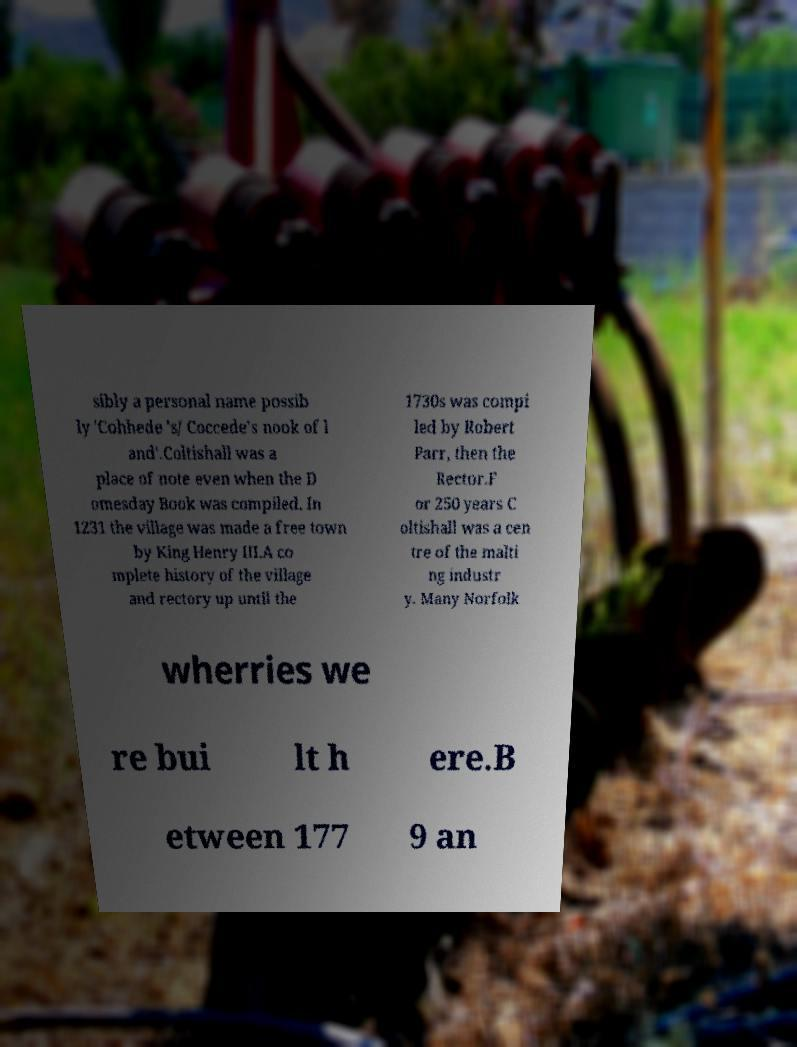I need the written content from this picture converted into text. Can you do that? sibly a personal name possib ly 'Cohhede 's/ Coccede's nook of l and'.Coltishall was a place of note even when the D omesday Book was compiled. In 1231 the village was made a free town by King Henry III.A co mplete history of the village and rectory up until the 1730s was compi led by Robert Parr, then the Rector.F or 250 years C oltishall was a cen tre of the malti ng industr y. Many Norfolk wherries we re bui lt h ere.B etween 177 9 an 